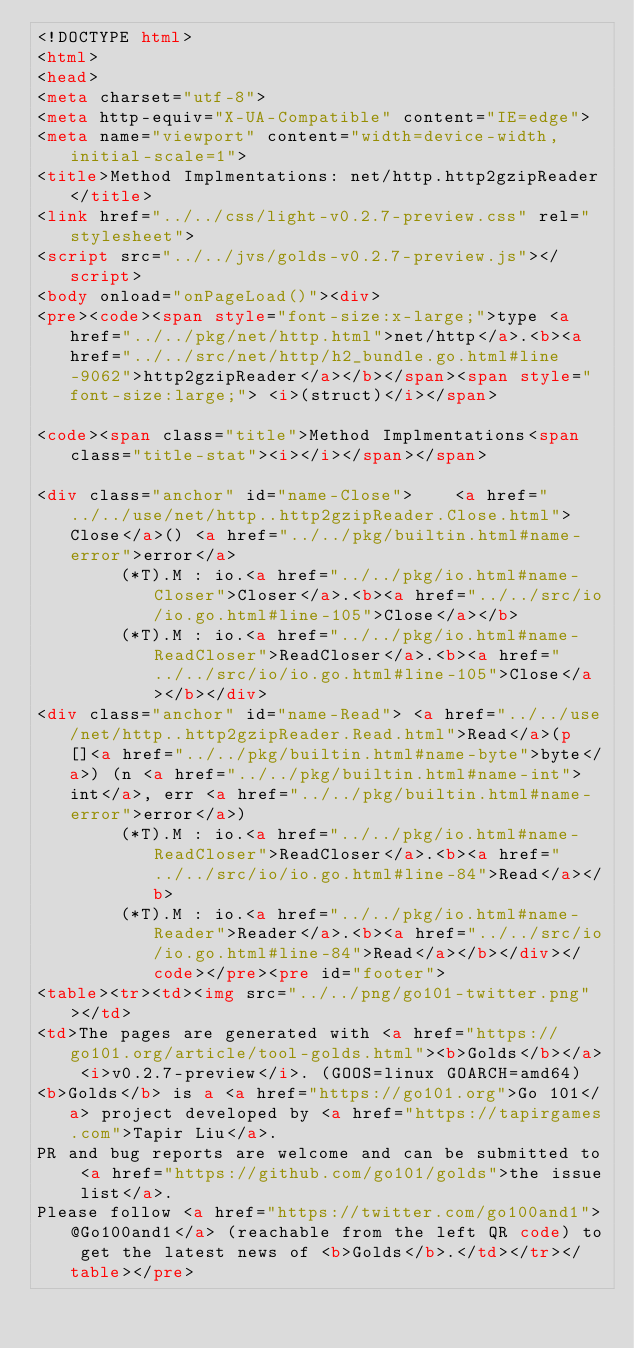<code> <loc_0><loc_0><loc_500><loc_500><_HTML_><!DOCTYPE html>
<html>
<head>
<meta charset="utf-8">
<meta http-equiv="X-UA-Compatible" content="IE=edge">
<meta name="viewport" content="width=device-width, initial-scale=1">
<title>Method Implmentations: net/http.http2gzipReader</title>
<link href="../../css/light-v0.2.7-preview.css" rel="stylesheet">
<script src="../../jvs/golds-v0.2.7-preview.js"></script>
<body onload="onPageLoad()"><div>
<pre><code><span style="font-size:x-large;">type <a href="../../pkg/net/http.html">net/http</a>.<b><a href="../../src/net/http/h2_bundle.go.html#line-9062">http2gzipReader</a></b></span><span style="font-size:large;"> <i>(struct)</i></span>

<code><span class="title">Method Implmentations<span class="title-stat"><i></i></span></span>

<div class="anchor" id="name-Close">	<a href="../../use/net/http..http2gzipReader.Close.html">Close</a>() <a href="../../pkg/builtin.html#name-error">error</a>
		(*T).M : io.<a href="../../pkg/io.html#name-Closer">Closer</a>.<b><a href="../../src/io/io.go.html#line-105">Close</a></b>
		(*T).M : io.<a href="../../pkg/io.html#name-ReadCloser">ReadCloser</a>.<b><a href="../../src/io/io.go.html#line-105">Close</a></b></div>
<div class="anchor" id="name-Read">	<a href="../../use/net/http..http2gzipReader.Read.html">Read</a>(p []<a href="../../pkg/builtin.html#name-byte">byte</a>) (n <a href="../../pkg/builtin.html#name-int">int</a>, err <a href="../../pkg/builtin.html#name-error">error</a>)
		(*T).M : io.<a href="../../pkg/io.html#name-ReadCloser">ReadCloser</a>.<b><a href="../../src/io/io.go.html#line-84">Read</a></b>
		(*T).M : io.<a href="../../pkg/io.html#name-Reader">Reader</a>.<b><a href="../../src/io/io.go.html#line-84">Read</a></b></div></code></pre><pre id="footer">
<table><tr><td><img src="../../png/go101-twitter.png"></td>
<td>The pages are generated with <a href="https://go101.org/article/tool-golds.html"><b>Golds</b></a> <i>v0.2.7-preview</i>. (GOOS=linux GOARCH=amd64)
<b>Golds</b> is a <a href="https://go101.org">Go 101</a> project developed by <a href="https://tapirgames.com">Tapir Liu</a>.
PR and bug reports are welcome and can be submitted to <a href="https://github.com/go101/golds">the issue list</a>.
Please follow <a href="https://twitter.com/go100and1">@Go100and1</a> (reachable from the left QR code) to get the latest news of <b>Golds</b>.</td></tr></table></pre></code> 